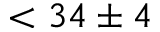Convert formula to latex. <formula><loc_0><loc_0><loc_500><loc_500>< 3 4 \pm 4</formula> 